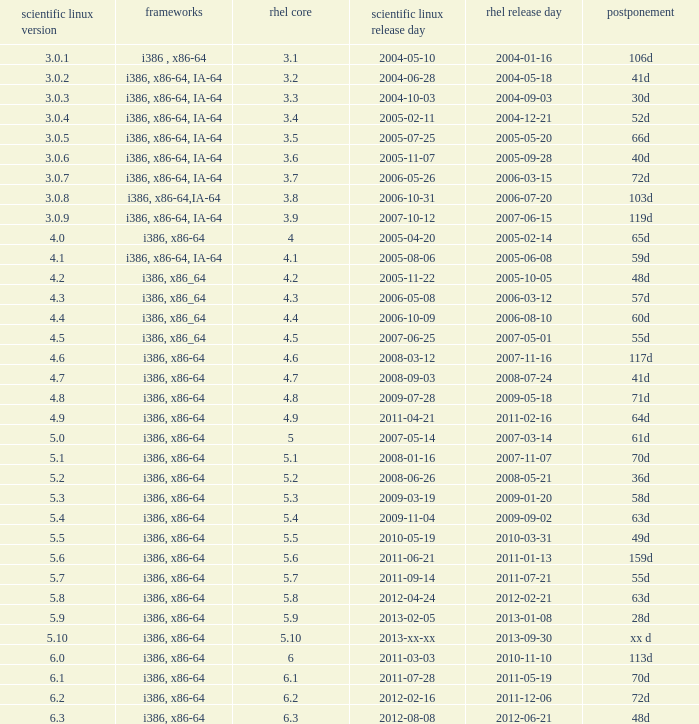Name the scientific linux release when delay is 28d 5.9. 